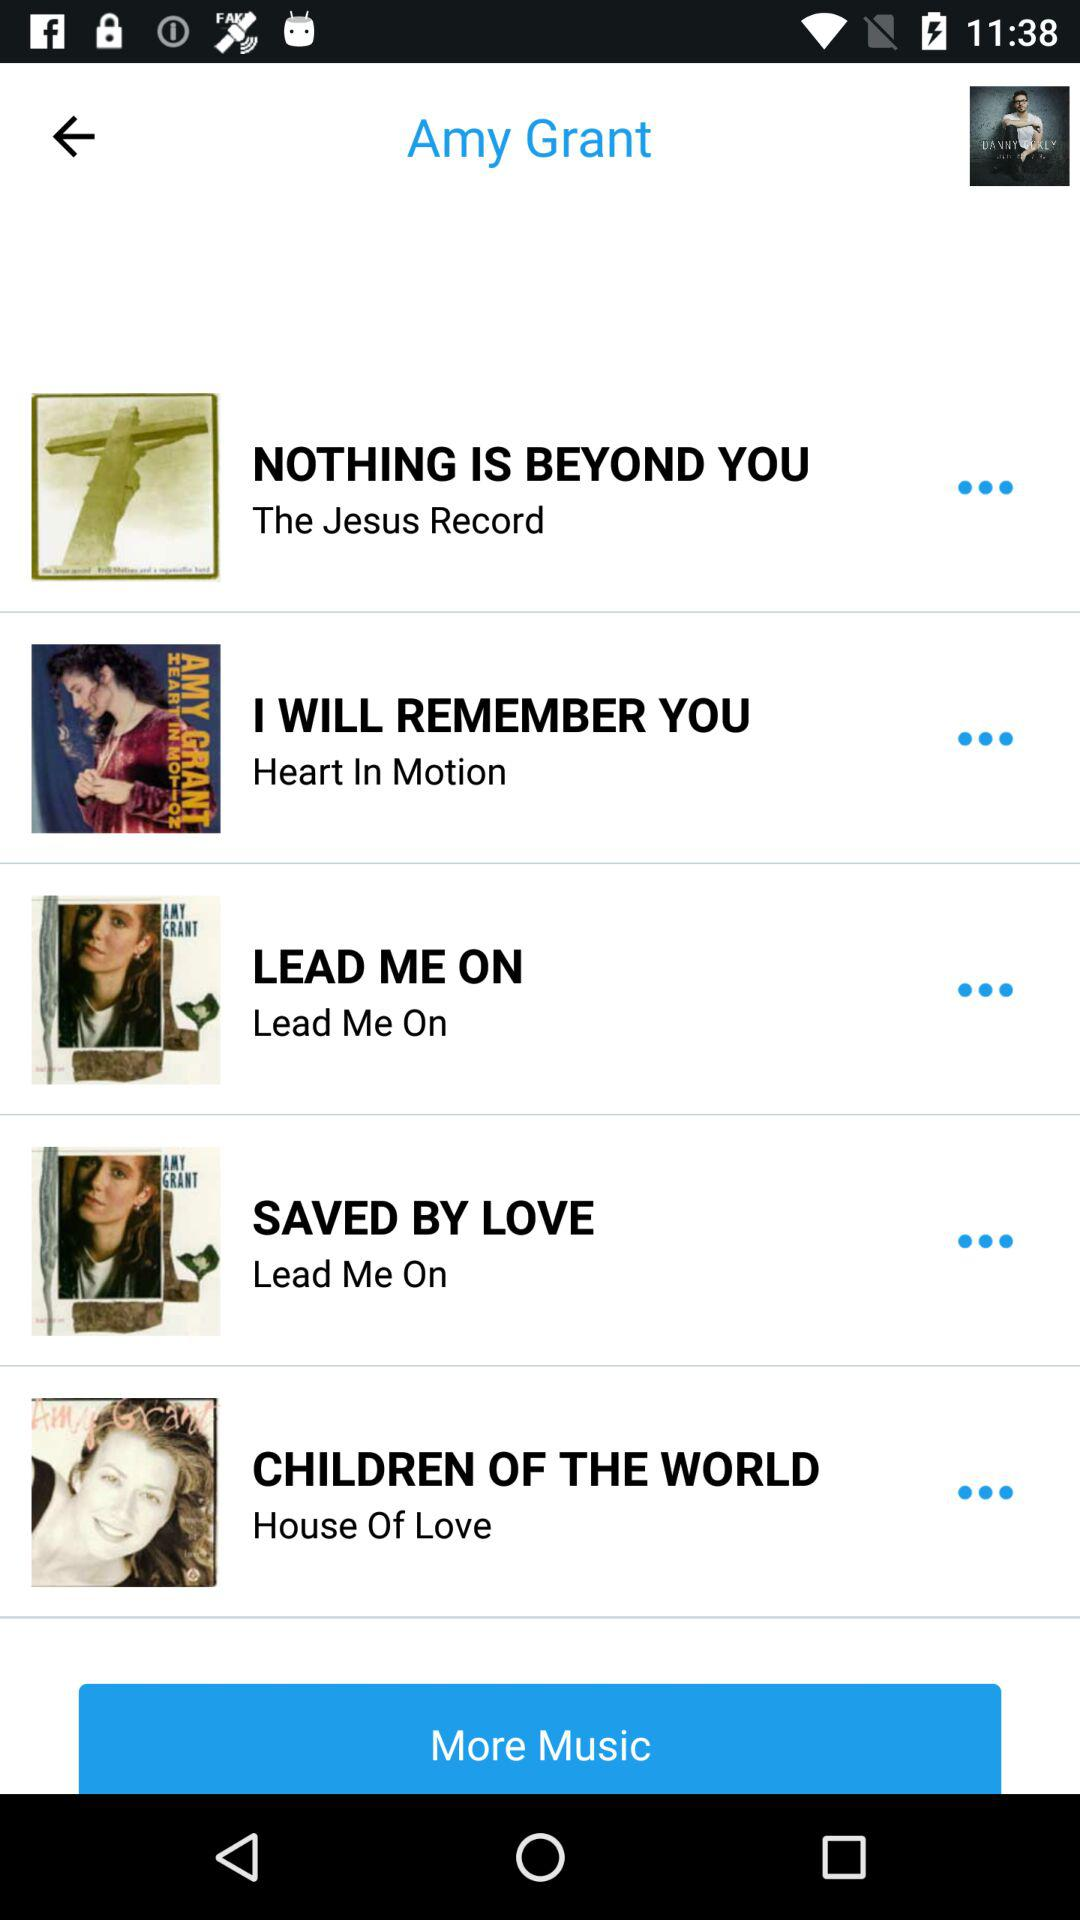"I WILL REMEMBER YOU" belongs to which album? It belongs to "Heart In Motion" album. 